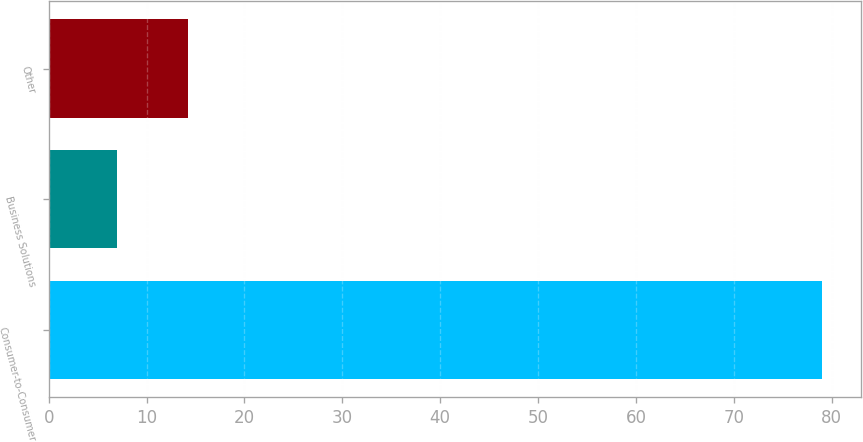Convert chart to OTSL. <chart><loc_0><loc_0><loc_500><loc_500><bar_chart><fcel>Consumer-to-Consumer<fcel>Business Solutions<fcel>Other<nl><fcel>79<fcel>7<fcel>14.2<nl></chart> 